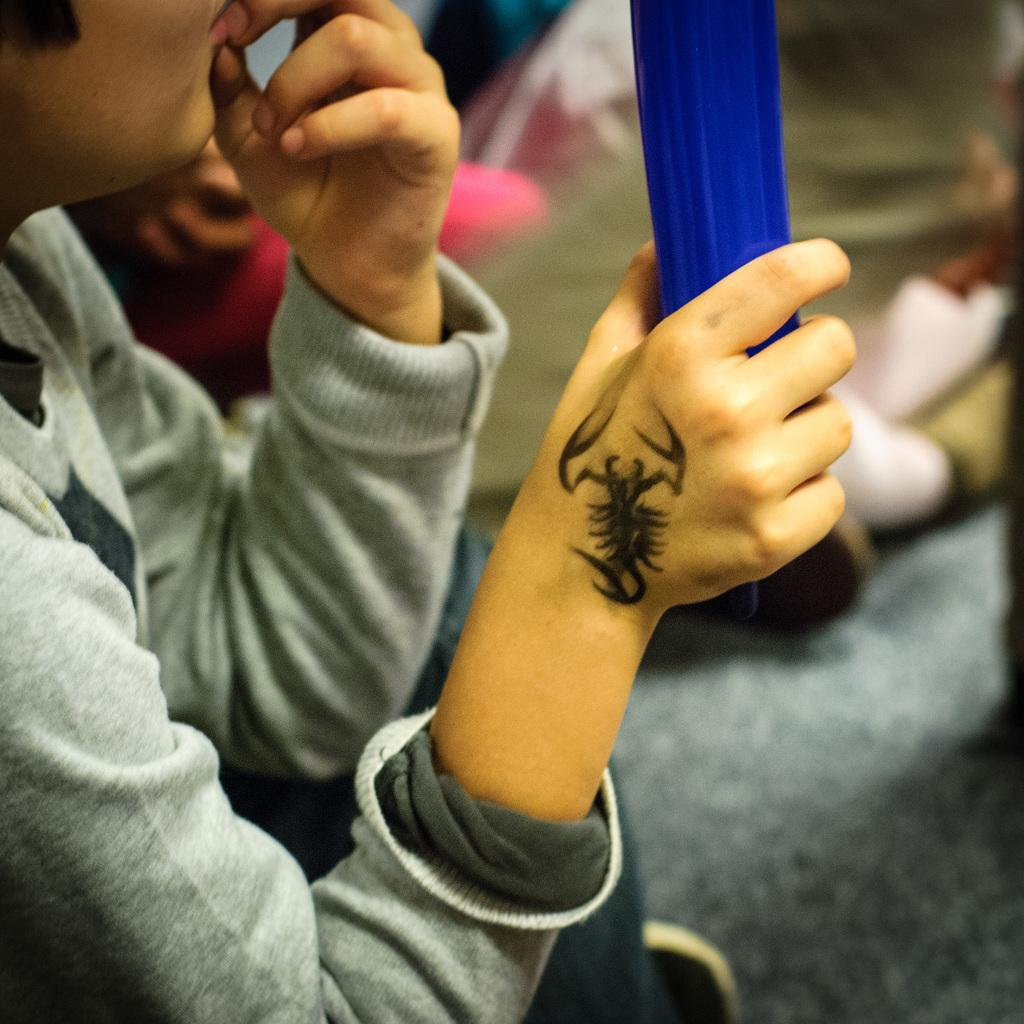What can be seen in the image? There is a person in the image. What is the person holding? The person is holding something, but the specific object cannot be determined from the facts provided. Can you describe any distinguishing features of the person? The person has a tattoo on their hand and is wearing a grey color T-shirt. What is the person's reaction to the disgusting smell in the image? There is no mention of a disgusting smell or any reaction from the person in the image. 